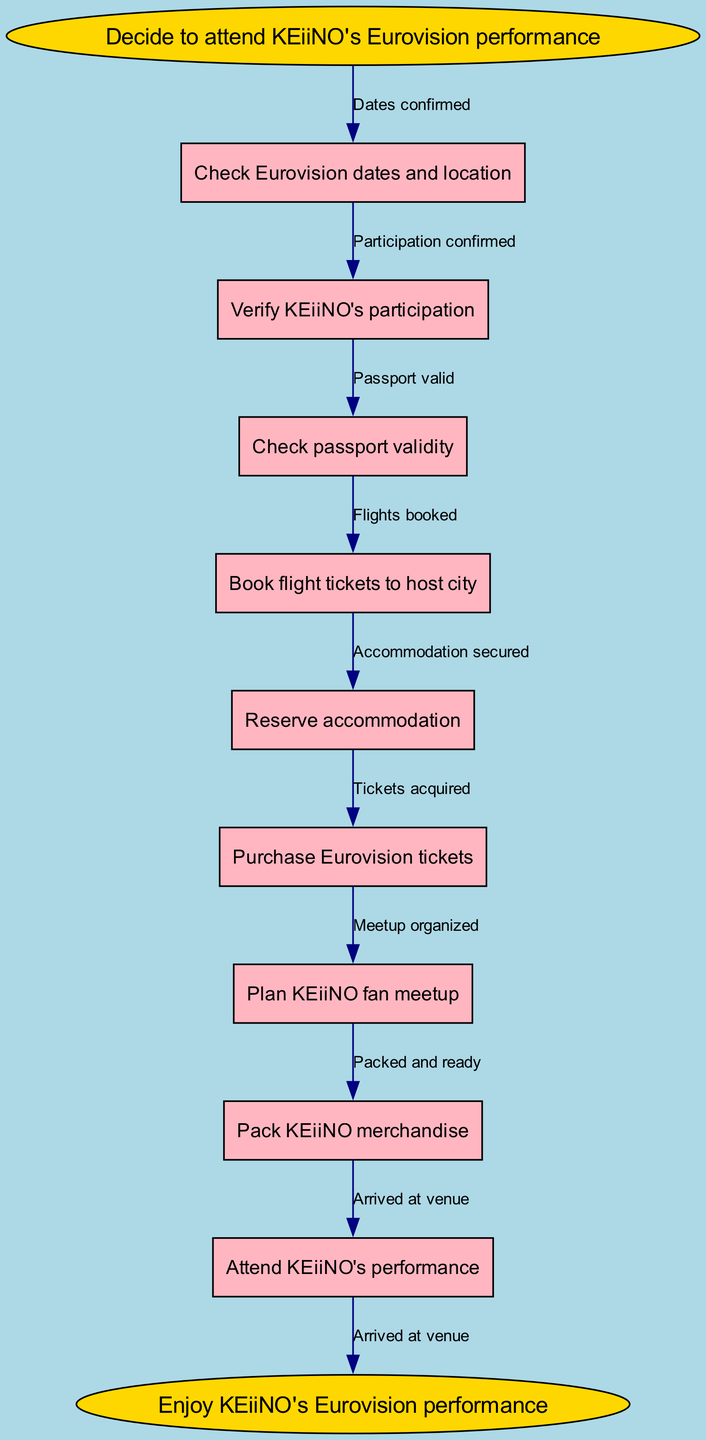What is the starting point in the diagram? The starting point is labeled as "Decide to attend KEiiNO's Eurovision performance" in the diagram.
Answer: Decide to attend KEiiNO's Eurovision performance How many nodes are in the diagram? There are a total of 9 nodes: 1 start node, 7 intermediate nodes, and 1 end node.
Answer: 9 What is the label of the last node before reaching the end node? The label of the last node before the end node is "Attend KEiiNO's performance."
Answer: Attend KEiiNO's performance Which step comes after verifying KEiiNO's participation? After verifying KEiiNO's participation, the next step in the flow is "Check passport validity."
Answer: Check passport validity What is the relationship between booking flight tickets and attending KEiiNO's performance? The relationship is that booking flight tickets is a prerequisite step that leads to attending KEiiNO's performance, illustrated by the edges in the flow.
Answer: Flight tickets booked What must be secured before you can attend KEiiNO's performance? Before attending, one must secure accommodation, which is illustrated as a required step after booking flight tickets.
Answer: Accommodation secured How many edges are there in the diagram? There are 8 edges, connecting all nodes from start to end.
Answer: 8 What follows the purchase of Eurovision tickets? Following the purchase of Eurovision tickets, the next step is to plan a KEiiNO fan meetup.
Answer: Plan KEiiNO fan meetup What indicates that the trip planning is complete? The trip planning is complete when you have the final edge that leads to the end node labeled "Enjoy KEiiNO's Eurovision performance."
Answer: Enjoy KEiiNO's Eurovision performance 